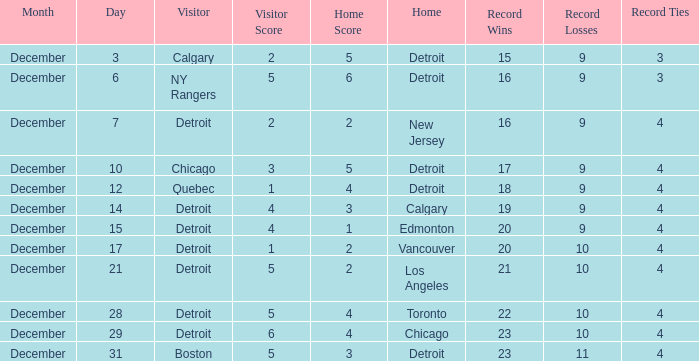What is the date for the home detroit and visitor was chicago? December 10. 